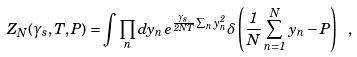<formula> <loc_0><loc_0><loc_500><loc_500>Z _ { N } ( \gamma _ { s } , T , P ) = \int \prod _ { n } d y _ { n } \, e ^ { \frac { \gamma _ { s } } { 2 N T } \sum _ { n } y _ { n } ^ { 2 } } \delta \left ( \frac { 1 } { N } \sum _ { n = 1 } ^ { N } \, y _ { n } - P \right ) \ ,</formula> 